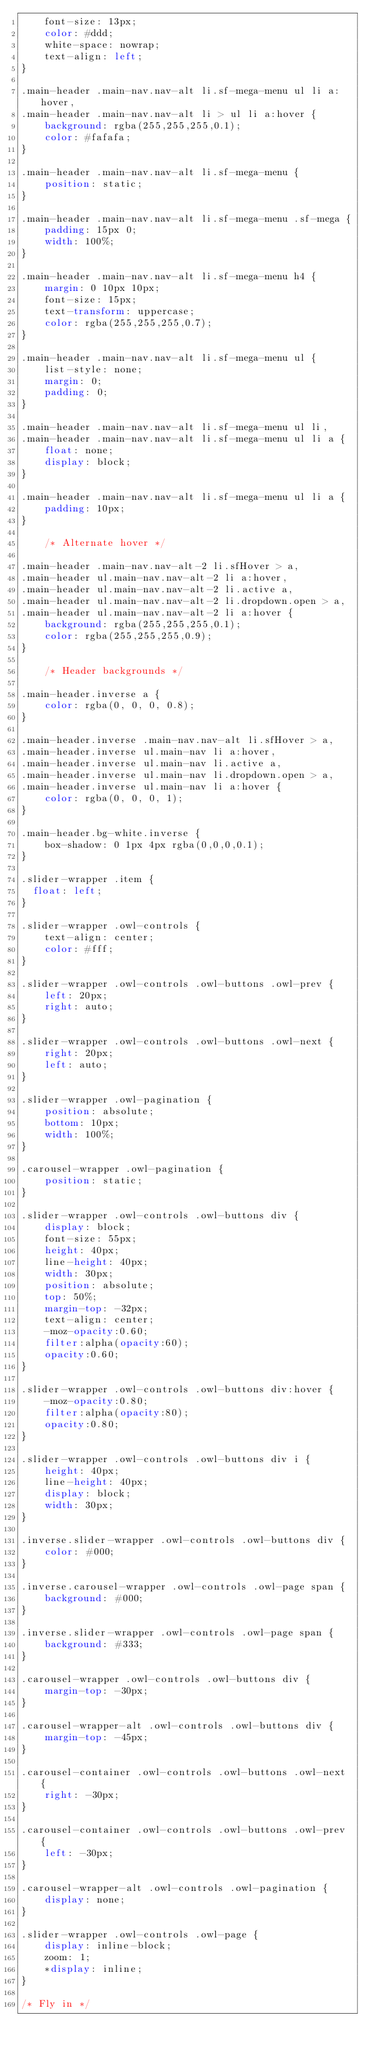Convert code to text. <code><loc_0><loc_0><loc_500><loc_500><_CSS_>	font-size: 13px;
	color: #ddd;
	white-space: nowrap;
	text-align: left;
}

.main-header .main-nav.nav-alt li.sf-mega-menu ul li a:hover, 
.main-header .main-nav.nav-alt li > ul li a:hover {
	background: rgba(255,255,255,0.1);
	color: #fafafa;
}

.main-header .main-nav.nav-alt li.sf-mega-menu {
	position: static;
}

.main-header .main-nav.nav-alt li.sf-mega-menu .sf-mega {
	padding: 15px 0;
    width: 100%;
}

.main-header .main-nav.nav-alt li.sf-mega-menu h4 {
	margin: 0 10px 10px;
	font-size: 15px;
	text-transform: uppercase;
	color: rgba(255,255,255,0.7);
}

.main-header .main-nav.nav-alt li.sf-mega-menu ul {
	list-style: none;
	margin: 0;
	padding: 0;
}

.main-header .main-nav.nav-alt li.sf-mega-menu ul li, 
.main-header .main-nav.nav-alt li.sf-mega-menu ul li a {
	float: none;
	display: block;
}

.main-header .main-nav.nav-alt li.sf-mega-menu ul li a {
	padding: 10px;
}

	/* Alternate hover */

.main-header .main-nav.nav-alt-2 li.sfHover > a, 
.main-header ul.main-nav.nav-alt-2 li a:hover, 
.main-header ul.main-nav.nav-alt-2 li.active a, 
.main-header ul.main-nav.nav-alt-2 li.dropdown.open > a, 
.main-header ul.main-nav.nav-alt-2 li a:hover {
	background: rgba(255,255,255,0.1);
	color: rgba(255,255,255,0.9);
}

	/* Header backgrounds */

.main-header.inverse a {
	color: rgba(0, 0, 0, 0.8);
}

.main-header.inverse .main-nav.nav-alt li.sfHover > a, 
.main-header.inverse ul.main-nav li a:hover, 
.main-header.inverse ul.main-nav li.active a, 
.main-header.inverse ul.main-nav li.dropdown.open > a, 
.main-header.inverse ul.main-nav li a:hover {
	color: rgba(0, 0, 0, 1);
}

.main-header.bg-white.inverse {
	box-shadow: 0 1px 4px rgba(0,0,0,0.1);
}

.slider-wrapper .item {
  float: left;
}

.slider-wrapper .owl-controls {
	text-align: center;
	color: #fff;
}

.slider-wrapper .owl-controls .owl-buttons .owl-prev {
	left: 20px;
	right: auto;
}

.slider-wrapper .owl-controls .owl-buttons .owl-next {
	right: 20px;
	left: auto;
}

.slider-wrapper .owl-pagination {
	position: absolute;
	bottom: 10px;
	width: 100%;
}

.carousel-wrapper .owl-pagination {
	position: static;
}

.slider-wrapper .owl-controls .owl-buttons div {
	display: block;
	font-size: 55px;
	height: 40px;
	line-height: 40px;
	width: 30px;
	position: absolute;
	top: 50%;
	margin-top: -32px;
	text-align: center;
	-moz-opacity:0.60;
	filter:alpha(opacity:60);
	opacity:0.60;
}

.slider-wrapper .owl-controls .owl-buttons div:hover {
	-moz-opacity:0.80;
	filter:alpha(opacity:80);
	opacity:0.80;
}

.slider-wrapper .owl-controls .owl-buttons div i {
	height: 40px;
	line-height: 40px;
	display: block;
	width: 30px;
}

.inverse.slider-wrapper .owl-controls .owl-buttons div {
	color: #000;
}

.inverse.carousel-wrapper .owl-controls .owl-page span {
	background: #000;
}

.inverse.slider-wrapper .owl-controls .owl-page span {
	background: #333;
}

.carousel-wrapper .owl-controls .owl-buttons div {
	margin-top: -30px;
}

.carousel-wrapper-alt .owl-controls .owl-buttons div {
	margin-top: -45px;
}

.carousel-container .owl-controls .owl-buttons .owl-next {
	right: -30px;
}

.carousel-container .owl-controls .owl-buttons .owl-prev {
	left: -30px;
}

.carousel-wrapper-alt .owl-controls .owl-pagination {
	display: none;
}

.slider-wrapper .owl-controls .owl-page {
	display: inline-block;
	zoom: 1;
	*display: inline;
}

/* Fly in */
</code> 